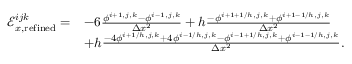Convert formula to latex. <formula><loc_0><loc_0><loc_500><loc_500>\begin{array} { r l } { \mathcal { E } _ { x , r e f i n e d } ^ { i j k } = } & { - 6 \frac { \phi ^ { i + 1 , j , k } - \phi ^ { i - 1 , j , k } } { \Delta x ^ { 2 } } + h \frac { - \phi ^ { i + 1 + 1 / h , j , k } + \phi ^ { i + 1 - 1 / h , j , k } } { \Delta x ^ { 2 } } } \\ & { + h \frac { - 4 \phi ^ { i + 1 / h , j , k } + 4 \phi ^ { i - 1 / h , j , k } - \phi ^ { i - 1 + 1 / h , j , k } + \phi ^ { i - 1 - 1 / h , j , k } } { \Delta x ^ { 2 } } . } \end{array}</formula> 